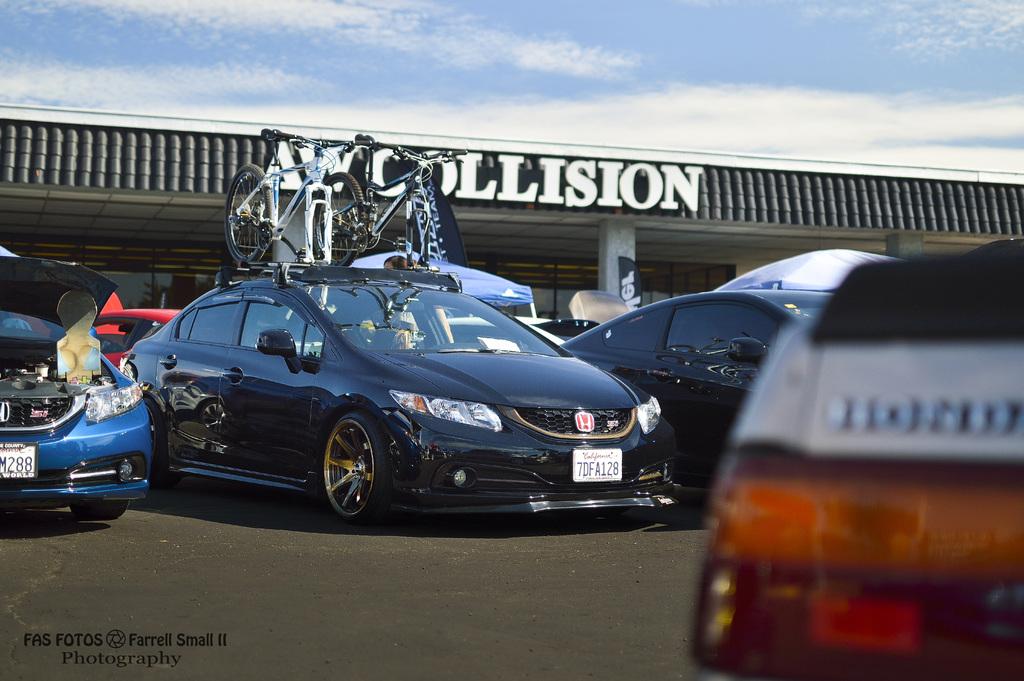What english word is mentioned on the right?
Ensure brevity in your answer.  Collision. What is the plate number visible on the black car?
Provide a short and direct response. 7dfa128. 